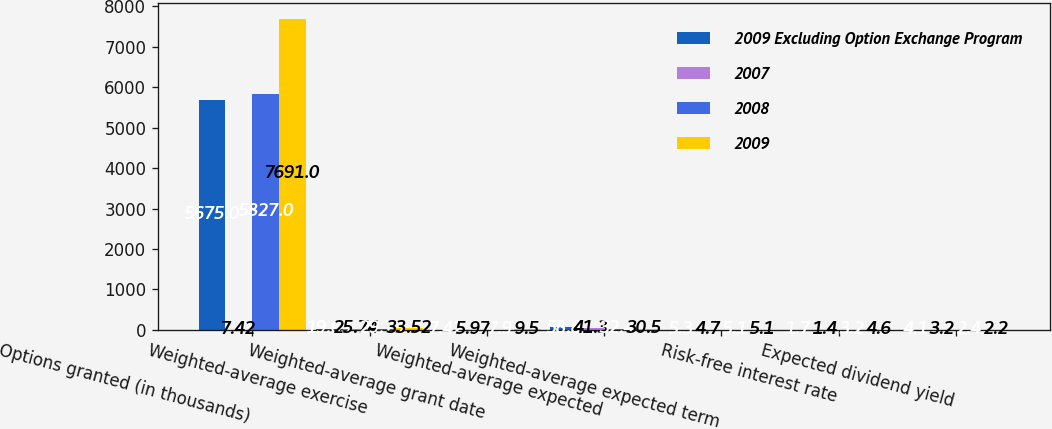Convert chart. <chart><loc_0><loc_0><loc_500><loc_500><stacked_bar_chart><ecel><fcel>Options granted (in thousands)<fcel>Weighted-average exercise<fcel>Weighted-average grant date<fcel>Weighted-average expected<fcel>Weighted-average expected term<fcel>Risk-free interest rate<fcel>Expected dividend yield<nl><fcel>2009 Excluding Option Exchange Program<fcel>5675<fcel>19.63<fcel>7.42<fcel>58.8<fcel>5.3<fcel>1.7<fcel>4.1<nl><fcel>2007<fcel>7.42<fcel>25.74<fcel>5.97<fcel>41.3<fcel>4.7<fcel>1.4<fcel>3.2<nl><fcel>2008<fcel>5827<fcel>29.79<fcel>7.9<fcel>32.4<fcel>5.1<fcel>3.2<fcel>2.4<nl><fcel>2009<fcel>7691<fcel>33.52<fcel>9.5<fcel>30.5<fcel>5.1<fcel>4.6<fcel>2.2<nl></chart> 